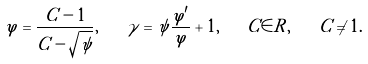<formula> <loc_0><loc_0><loc_500><loc_500>\varphi = \frac { C - 1 } { C - \sqrt { \psi } } , \quad \gamma = \psi \frac { \varphi ^ { \prime } } { \varphi } + 1 , \quad C \in { R } , \quad C \neq 1 .</formula> 